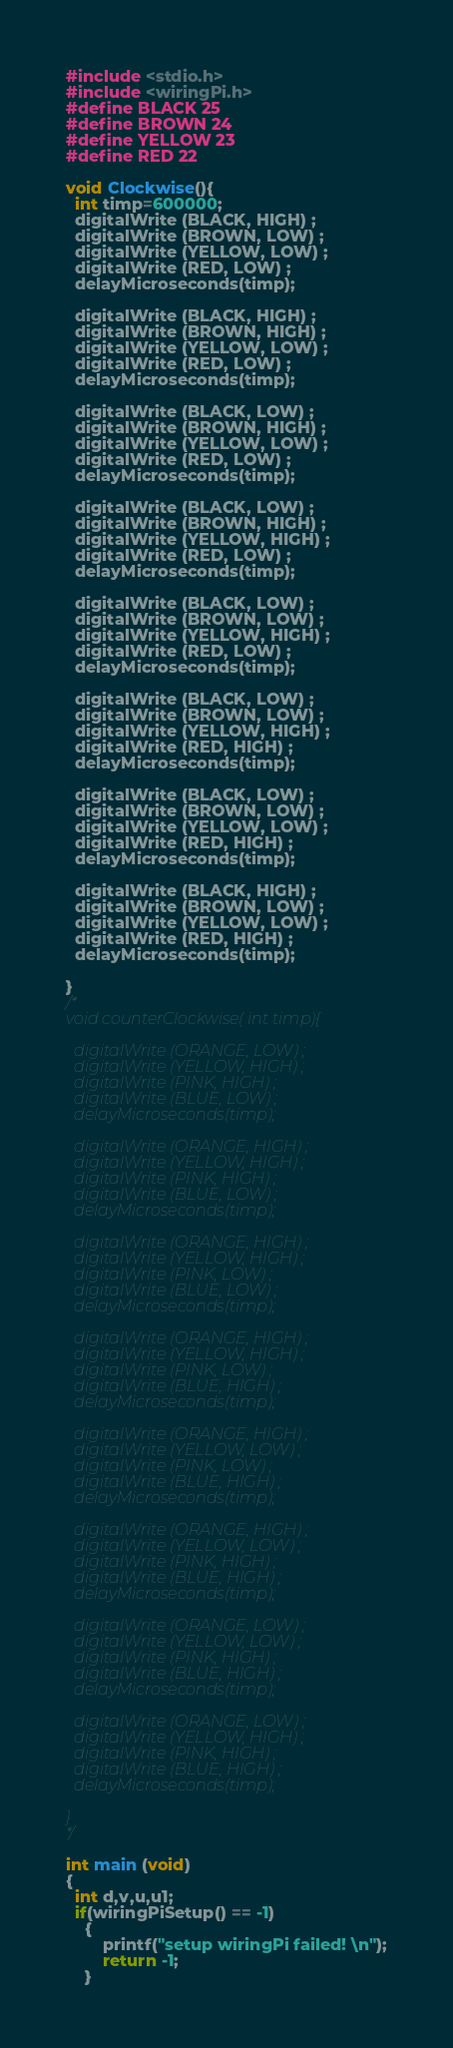<code> <loc_0><loc_0><loc_500><loc_500><_C_>#include <stdio.h>
#include <wiringPi.h>
#define BLACK 25
#define BROWN 24
#define YELLOW 23
#define RED 22

void Clockwise(){
  int timp=600000;
  digitalWrite (BLACK, HIGH) ;
  digitalWrite (BROWN, LOW) ;
  digitalWrite (YELLOW, LOW) ;
  digitalWrite (RED, LOW) ;
  delayMicroseconds(timp);

  digitalWrite (BLACK, HIGH) ;
  digitalWrite (BROWN, HIGH) ;
  digitalWrite (YELLOW, LOW) ;
  digitalWrite (RED, LOW) ;
  delayMicroseconds(timp);

  digitalWrite (BLACK, LOW) ;
  digitalWrite (BROWN, HIGH) ;
  digitalWrite (YELLOW, LOW) ;
  digitalWrite (RED, LOW) ;
  delayMicroseconds(timp);

  digitalWrite (BLACK, LOW) ;
  digitalWrite (BROWN, HIGH) ;
  digitalWrite (YELLOW, HIGH) ;
  digitalWrite (RED, LOW) ;
  delayMicroseconds(timp);

  digitalWrite (BLACK, LOW) ;
  digitalWrite (BROWN, LOW) ;
  digitalWrite (YELLOW, HIGH) ;
  digitalWrite (RED, LOW) ;
  delayMicroseconds(timp);

  digitalWrite (BLACK, LOW) ;
  digitalWrite (BROWN, LOW) ;
  digitalWrite (YELLOW, HIGH) ;
  digitalWrite (RED, HIGH) ;
  delayMicroseconds(timp);

  digitalWrite (BLACK, LOW) ;
  digitalWrite (BROWN, LOW) ;
  digitalWrite (YELLOW, LOW) ;
  digitalWrite (RED, HIGH) ;
  delayMicroseconds(timp);

  digitalWrite (BLACK, HIGH) ;
  digitalWrite (BROWN, LOW) ;
  digitalWrite (YELLOW, LOW) ;
  digitalWrite (RED, HIGH) ;
  delayMicroseconds(timp);

}
/*
void counterClockwise( int timp){

  digitalWrite (ORANGE, LOW) ;
  digitalWrite (YELLOW, HIGH) ;
  digitalWrite (PINK, HIGH) ;
  digitalWrite (BLUE, LOW) ;
  delayMicroseconds(timp);

  digitalWrite (ORANGE, HIGH) ;
  digitalWrite (YELLOW, HIGH) ;
  digitalWrite (PINK, HIGH) ;
  digitalWrite (BLUE, LOW) ;
  delayMicroseconds(timp);

  digitalWrite (ORANGE, HIGH) ;
  digitalWrite (YELLOW, HIGH) ;
  digitalWrite (PINK, LOW) ;
  digitalWrite (BLUE, LOW) ;
  delayMicroseconds(timp);

  digitalWrite (ORANGE, HIGH) ;
  digitalWrite (YELLOW, HIGH) ;
  digitalWrite (PINK, LOW) ;
  digitalWrite (BLUE, HIGH) ;
  delayMicroseconds(timp);

  digitalWrite (ORANGE, HIGH) ;
  digitalWrite (YELLOW, LOW) ;
  digitalWrite (PINK, LOW) ;
  digitalWrite (BLUE, HIGH) ;
  delayMicroseconds(timp);

  digitalWrite (ORANGE, HIGH) ;
  digitalWrite (YELLOW, LOW) ;
  digitalWrite (PINK, HIGH) ;
  digitalWrite (BLUE, HIGH) ;
  delayMicroseconds(timp);

  digitalWrite (ORANGE, LOW) ;
  digitalWrite (YELLOW, LOW) ;
  digitalWrite (PINK, HIGH) ;
  digitalWrite (BLUE, HIGH) ;
  delayMicroseconds(timp);

  digitalWrite (ORANGE, LOW) ;
  digitalWrite (YELLOW, HIGH) ;
  digitalWrite (PINK, HIGH) ;
  digitalWrite (BLUE, HIGH) ;
  delayMicroseconds(timp);

}
*/

int main (void)
{
  int d,v,u,u1;
  if(wiringPiSetup() == -1)
	{
        printf("setup wiringPi failed! \n");
        return -1;
	}</code> 